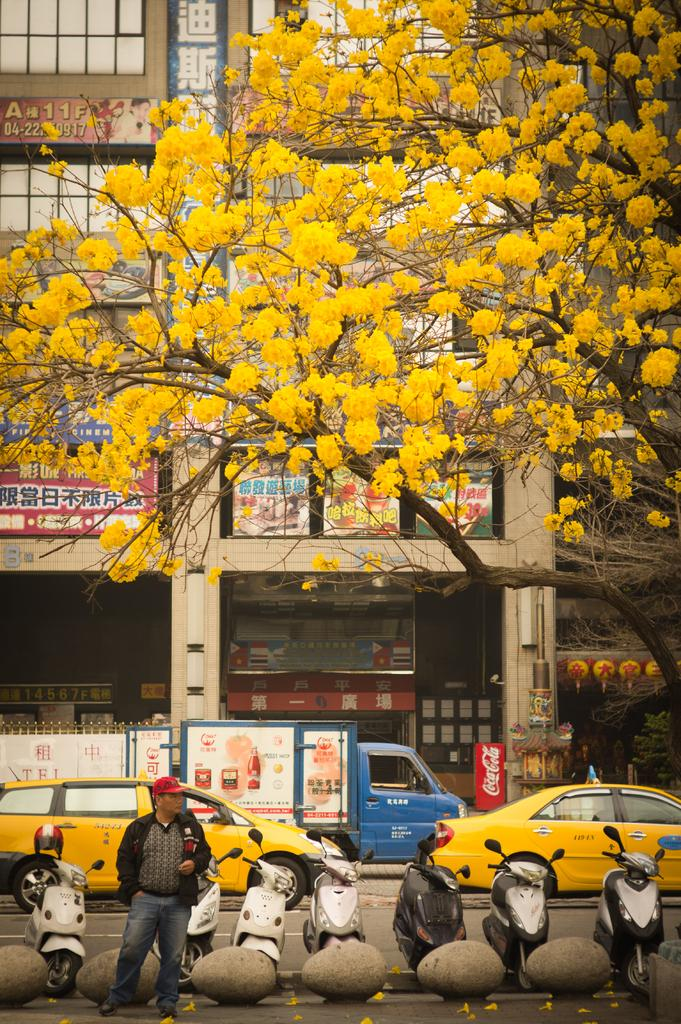Provide a one-sentence caption for the provided image. a street scene with a truck that has Tel on it in some foreign language. 